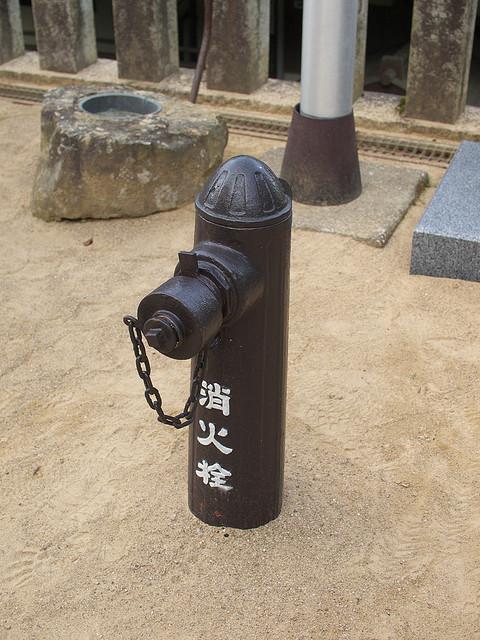Is this in a foreign country?
Answer briefly. Yes. What color is the hydrant?
Quick response, please. Black. What language is seen?
Quick response, please. Chinese. 